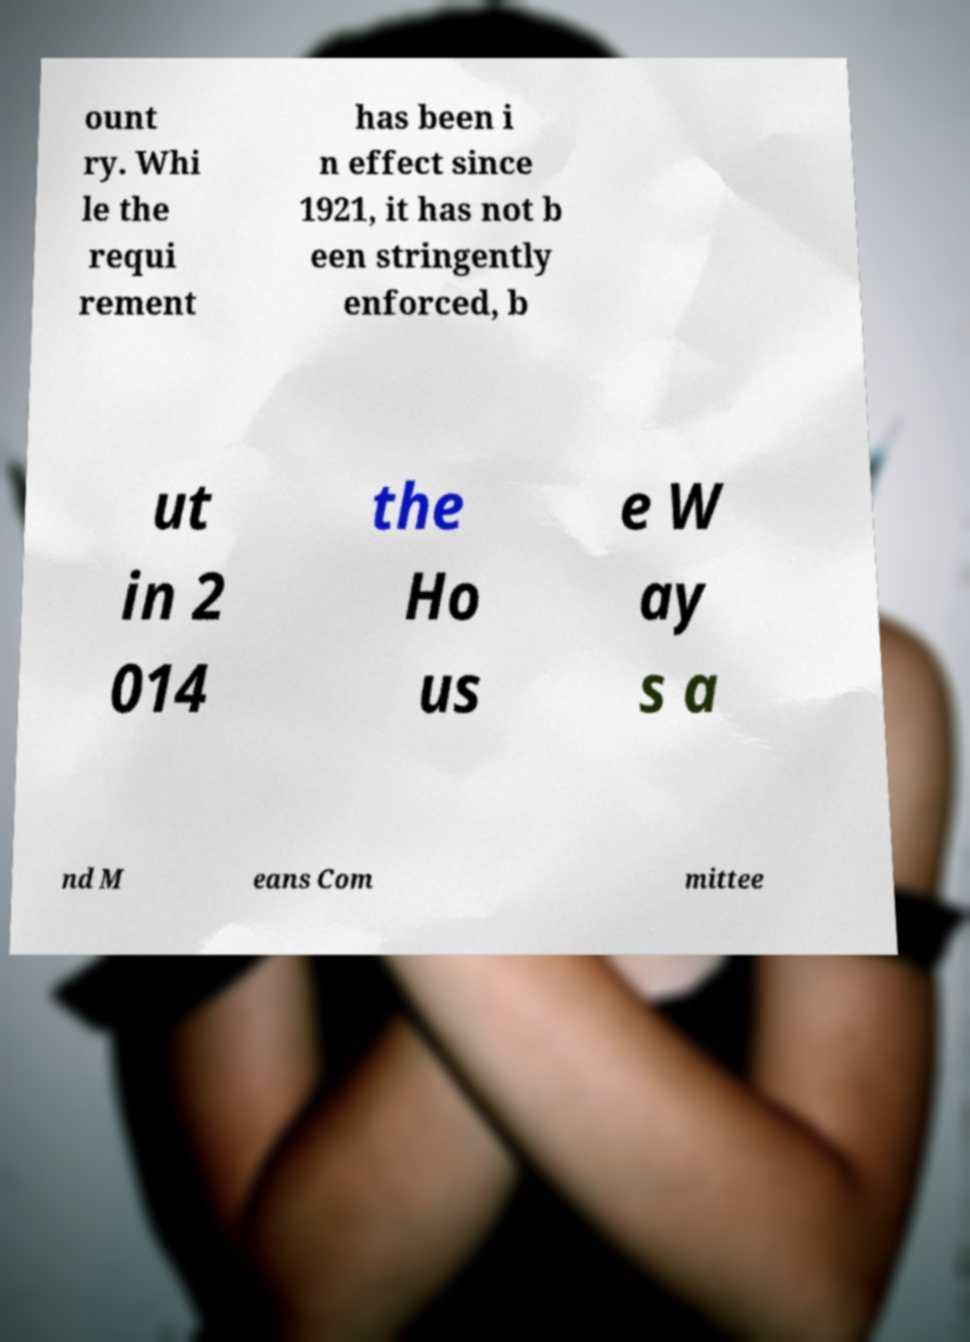Can you accurately transcribe the text from the provided image for me? ount ry. Whi le the requi rement has been i n effect since 1921, it has not b een stringently enforced, b ut in 2 014 the Ho us e W ay s a nd M eans Com mittee 